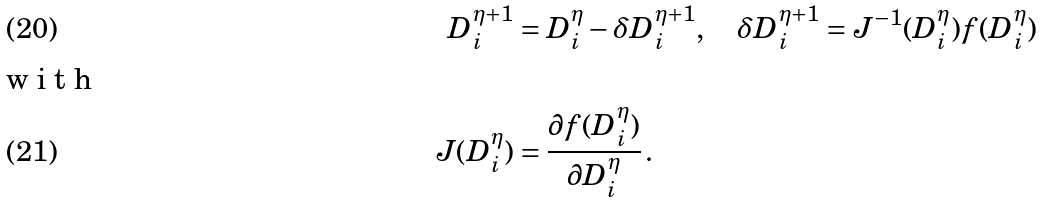<formula> <loc_0><loc_0><loc_500><loc_500>D _ { i } ^ { \eta + 1 } & = D _ { i } ^ { \eta } - \delta D _ { i } ^ { \eta + 1 } , \quad \delta D _ { i } ^ { \eta + 1 } = J ^ { - 1 } ( D _ { i } ^ { \eta } ) f ( D _ { i } ^ { \eta } ) \\ \intertext { w i t h } J ( D _ { i } ^ { \eta } ) & = \frac { \partial f ( D _ { i } ^ { \eta } ) } { \partial D _ { i } ^ { \eta } } \, .</formula> 